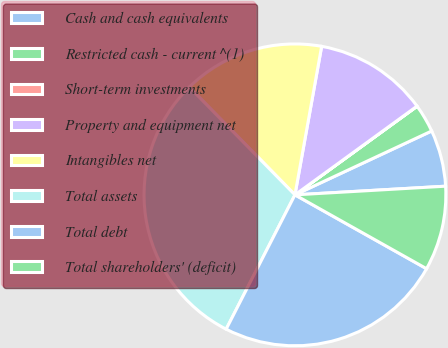<chart> <loc_0><loc_0><loc_500><loc_500><pie_chart><fcel>Cash and cash equivalents<fcel>Restricted cash - current ^(1)<fcel>Short-term investments<fcel>Property and equipment net<fcel>Intangibles net<fcel>Total assets<fcel>Total debt<fcel>Total shareholders' (deficit)<nl><fcel>6.04%<fcel>3.03%<fcel>0.02%<fcel>12.16%<fcel>15.17%<fcel>30.12%<fcel>24.39%<fcel>9.05%<nl></chart> 